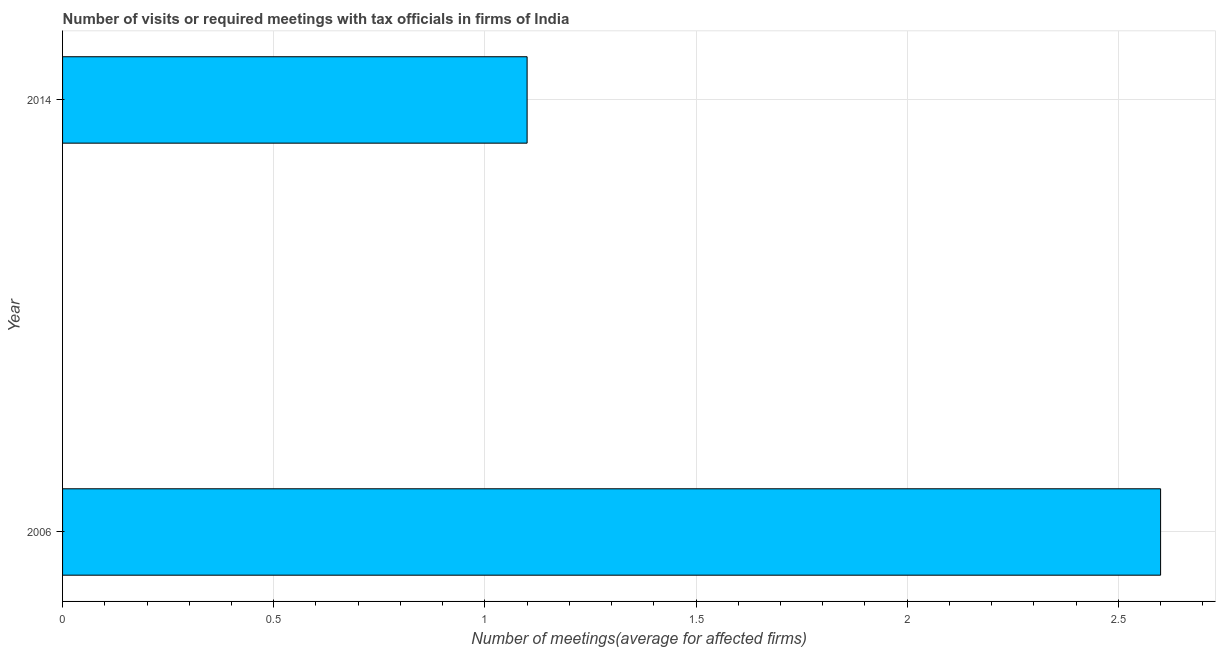Does the graph contain grids?
Make the answer very short. Yes. What is the title of the graph?
Your answer should be compact. Number of visits or required meetings with tax officials in firms of India. What is the label or title of the X-axis?
Offer a terse response. Number of meetings(average for affected firms). What is the label or title of the Y-axis?
Keep it short and to the point. Year. What is the number of required meetings with tax officials in 2006?
Your response must be concise. 2.6. In which year was the number of required meetings with tax officials minimum?
Ensure brevity in your answer.  2014. What is the sum of the number of required meetings with tax officials?
Offer a terse response. 3.7. What is the average number of required meetings with tax officials per year?
Make the answer very short. 1.85. What is the median number of required meetings with tax officials?
Give a very brief answer. 1.85. In how many years, is the number of required meetings with tax officials greater than 0.8 ?
Offer a terse response. 2. What is the ratio of the number of required meetings with tax officials in 2006 to that in 2014?
Make the answer very short. 2.36. In how many years, is the number of required meetings with tax officials greater than the average number of required meetings with tax officials taken over all years?
Your answer should be compact. 1. How many bars are there?
Provide a succinct answer. 2. Are all the bars in the graph horizontal?
Your answer should be compact. Yes. How many years are there in the graph?
Offer a terse response. 2. Are the values on the major ticks of X-axis written in scientific E-notation?
Give a very brief answer. No. What is the Number of meetings(average for affected firms) of 2014?
Give a very brief answer. 1.1. What is the ratio of the Number of meetings(average for affected firms) in 2006 to that in 2014?
Offer a terse response. 2.36. 